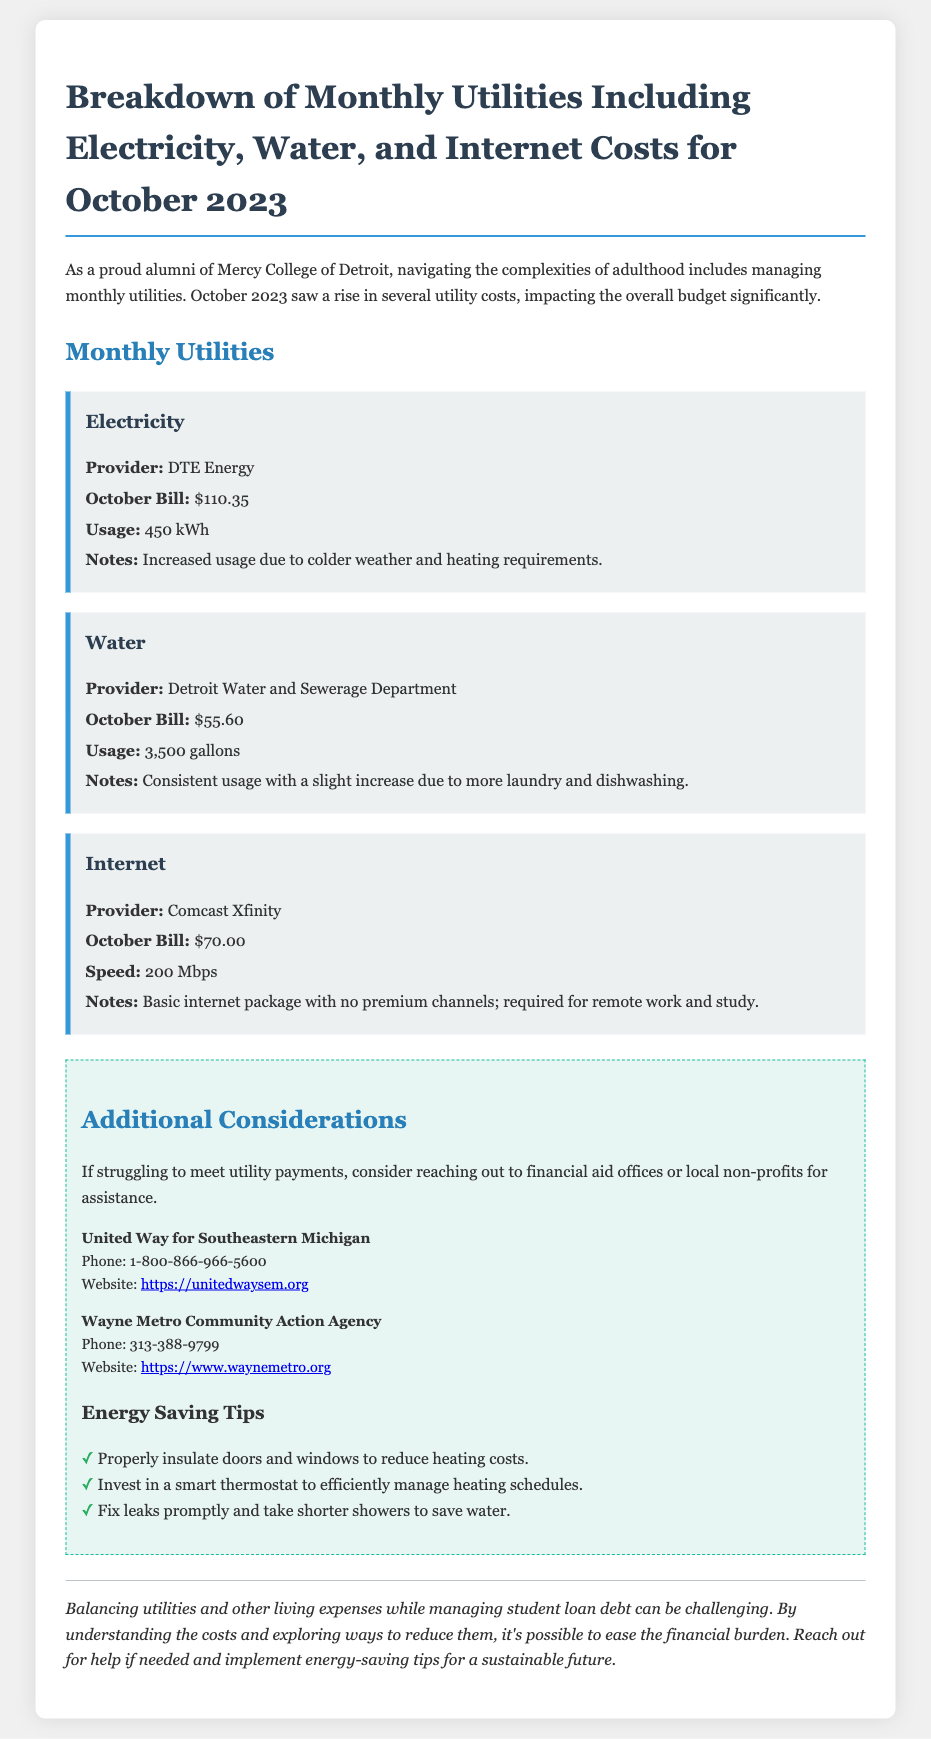What is the electricity bill for October 2023? The electricity bill is mentioned in the utilities breakdown section, which is $110.35.
Answer: $110.35 Who is the water provider? The document specifies the provider for water, which is the Detroit Water and Sewerage Department.
Answer: Detroit Water and Sewerage Department What is the internet speed provided? The internet speed is listed under the internet utility section as 200 Mbps.
Answer: 200 Mbps What factors contributed to increased electricity usage? The notes section under electricity mentions increased usage is due to colder weather and heating requirements.
Answer: Colder weather and heating requirements How much water was used in October 2023? The monthly water usage is specified as 3,500 gallons in the water utility section.
Answer: 3,500 gallons What should you do if you struggle to meet utility payments? The document provides advice in the additional information section about reaching out for assistance.
Answer: Reach out for assistance What is the name of the internet provider? The internet section specifies that the provider is Comcast Xfinity.
Answer: Comcast Xfinity List one tip for saving energy mentioned in the document. The energy-saving tips section provides several options, one of which is to properly insulate doors and windows.
Answer: Properly insulate doors and windows 